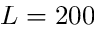Convert formula to latex. <formula><loc_0><loc_0><loc_500><loc_500>L = 2 0 0</formula> 